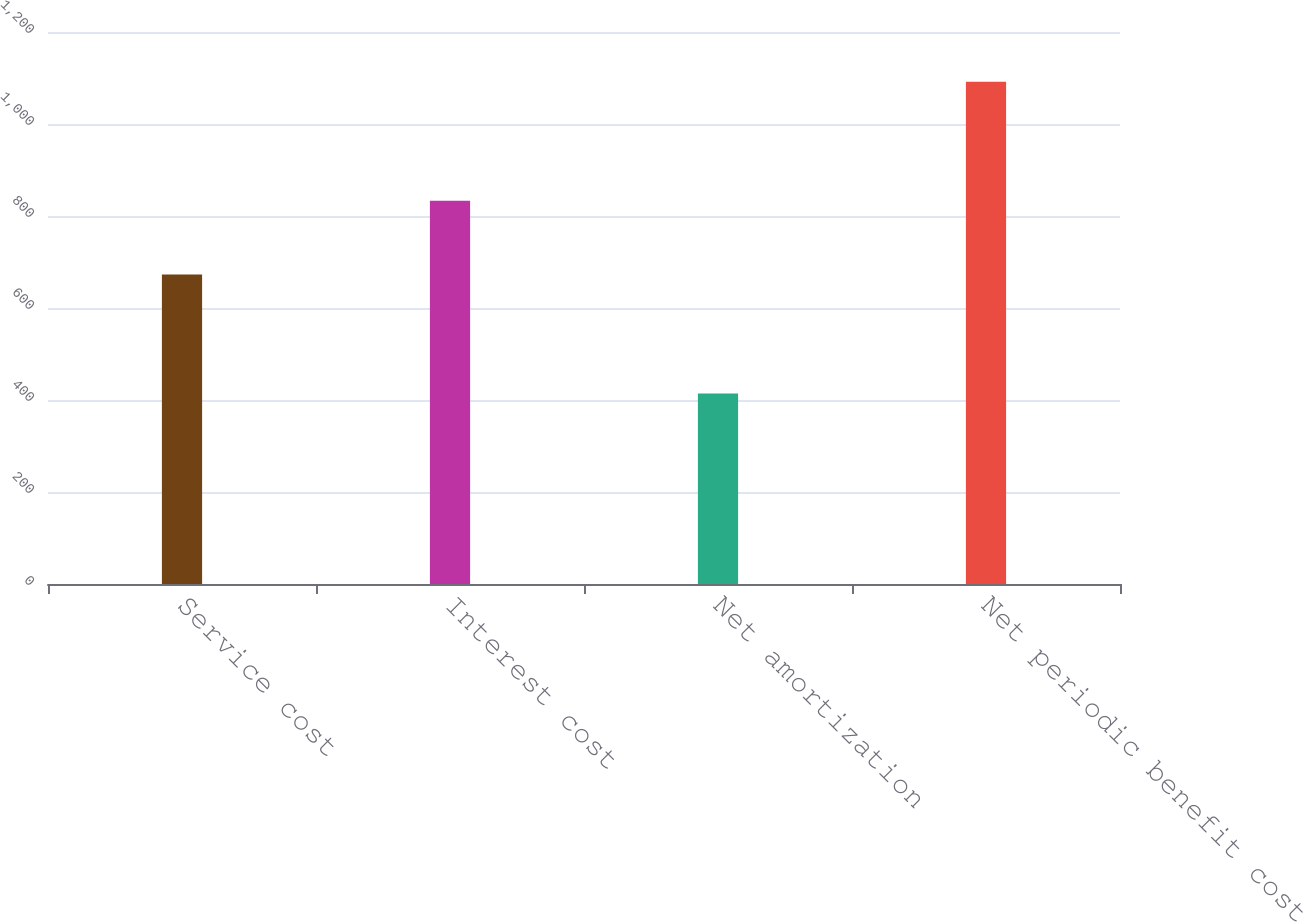<chart> <loc_0><loc_0><loc_500><loc_500><bar_chart><fcel>Service cost<fcel>Interest cost<fcel>Net amortization<fcel>Net periodic benefit cost<nl><fcel>673<fcel>833<fcel>414<fcel>1092<nl></chart> 